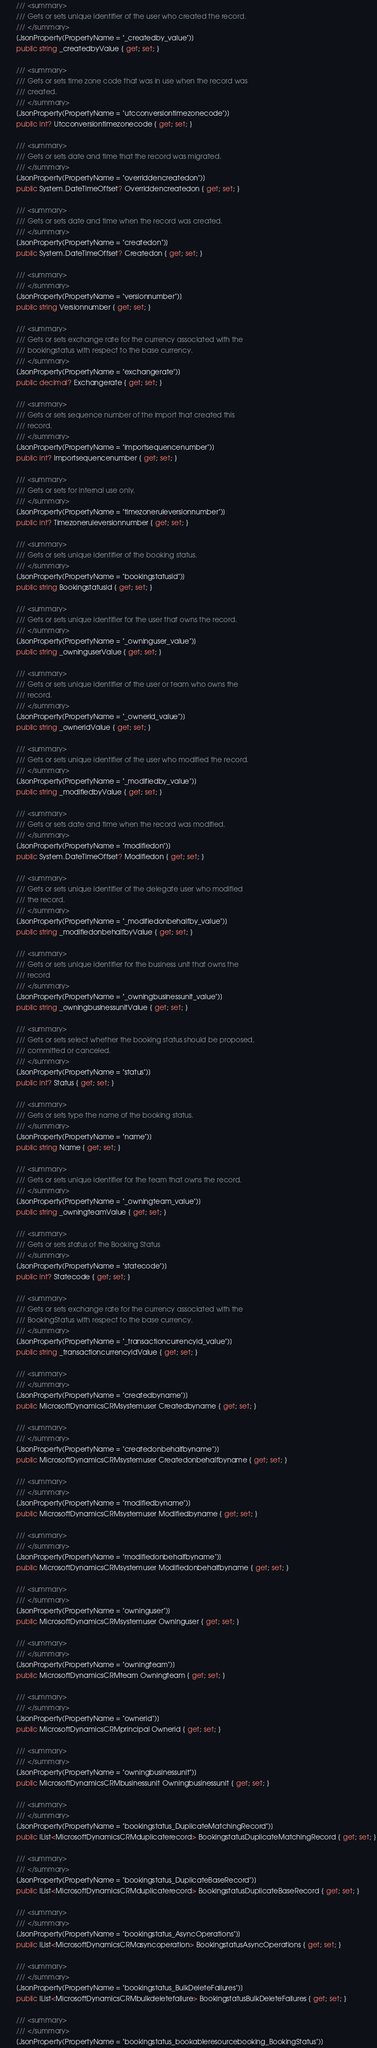Convert code to text. <code><loc_0><loc_0><loc_500><loc_500><_C#_>        /// <summary>
        /// Gets or sets unique identifier of the user who created the record.
        /// </summary>
        [JsonProperty(PropertyName = "_createdby_value")]
        public string _createdbyValue { get; set; }

        /// <summary>
        /// Gets or sets time zone code that was in use when the record was
        /// created.
        /// </summary>
        [JsonProperty(PropertyName = "utcconversiontimezonecode")]
        public int? Utcconversiontimezonecode { get; set; }

        /// <summary>
        /// Gets or sets date and time that the record was migrated.
        /// </summary>
        [JsonProperty(PropertyName = "overriddencreatedon")]
        public System.DateTimeOffset? Overriddencreatedon { get; set; }

        /// <summary>
        /// Gets or sets date and time when the record was created.
        /// </summary>
        [JsonProperty(PropertyName = "createdon")]
        public System.DateTimeOffset? Createdon { get; set; }

        /// <summary>
        /// </summary>
        [JsonProperty(PropertyName = "versionnumber")]
        public string Versionnumber { get; set; }

        /// <summary>
        /// Gets or sets exchange rate for the currency associated with the
        /// bookingstatus with respect to the base currency.
        /// </summary>
        [JsonProperty(PropertyName = "exchangerate")]
        public decimal? Exchangerate { get; set; }

        /// <summary>
        /// Gets or sets sequence number of the import that created this
        /// record.
        /// </summary>
        [JsonProperty(PropertyName = "importsequencenumber")]
        public int? Importsequencenumber { get; set; }

        /// <summary>
        /// Gets or sets for internal use only.
        /// </summary>
        [JsonProperty(PropertyName = "timezoneruleversionnumber")]
        public int? Timezoneruleversionnumber { get; set; }

        /// <summary>
        /// Gets or sets unique identifier of the booking status.
        /// </summary>
        [JsonProperty(PropertyName = "bookingstatusid")]
        public string Bookingstatusid { get; set; }

        /// <summary>
        /// Gets or sets unique identifier for the user that owns the record.
        /// </summary>
        [JsonProperty(PropertyName = "_owninguser_value")]
        public string _owninguserValue { get; set; }

        /// <summary>
        /// Gets or sets unique identifier of the user or team who owns the
        /// record.
        /// </summary>
        [JsonProperty(PropertyName = "_ownerid_value")]
        public string _owneridValue { get; set; }

        /// <summary>
        /// Gets or sets unique identifier of the user who modified the record.
        /// </summary>
        [JsonProperty(PropertyName = "_modifiedby_value")]
        public string _modifiedbyValue { get; set; }

        /// <summary>
        /// Gets or sets date and time when the record was modified.
        /// </summary>
        [JsonProperty(PropertyName = "modifiedon")]
        public System.DateTimeOffset? Modifiedon { get; set; }

        /// <summary>
        /// Gets or sets unique identifier of the delegate user who modified
        /// the record.
        /// </summary>
        [JsonProperty(PropertyName = "_modifiedonbehalfby_value")]
        public string _modifiedonbehalfbyValue { get; set; }

        /// <summary>
        /// Gets or sets unique identifier for the business unit that owns the
        /// record
        /// </summary>
        [JsonProperty(PropertyName = "_owningbusinessunit_value")]
        public string _owningbusinessunitValue { get; set; }

        /// <summary>
        /// Gets or sets select whether the booking status should be proposed,
        /// committed or canceled.
        /// </summary>
        [JsonProperty(PropertyName = "status")]
        public int? Status { get; set; }

        /// <summary>
        /// Gets or sets type the name of the booking status.
        /// </summary>
        [JsonProperty(PropertyName = "name")]
        public string Name { get; set; }

        /// <summary>
        /// Gets or sets unique identifier for the team that owns the record.
        /// </summary>
        [JsonProperty(PropertyName = "_owningteam_value")]
        public string _owningteamValue { get; set; }

        /// <summary>
        /// Gets or sets status of the Booking Status
        /// </summary>
        [JsonProperty(PropertyName = "statecode")]
        public int? Statecode { get; set; }

        /// <summary>
        /// Gets or sets exchange rate for the currency associated with the
        /// BookingStatus with respect to the base currency.
        /// </summary>
        [JsonProperty(PropertyName = "_transactioncurrencyid_value")]
        public string _transactioncurrencyidValue { get; set; }

        /// <summary>
        /// </summary>
        [JsonProperty(PropertyName = "createdbyname")]
        public MicrosoftDynamicsCRMsystemuser Createdbyname { get; set; }

        /// <summary>
        /// </summary>
        [JsonProperty(PropertyName = "createdonbehalfbyname")]
        public MicrosoftDynamicsCRMsystemuser Createdonbehalfbyname { get; set; }

        /// <summary>
        /// </summary>
        [JsonProperty(PropertyName = "modifiedbyname")]
        public MicrosoftDynamicsCRMsystemuser Modifiedbyname { get; set; }

        /// <summary>
        /// </summary>
        [JsonProperty(PropertyName = "modifiedonbehalfbyname")]
        public MicrosoftDynamicsCRMsystemuser Modifiedonbehalfbyname { get; set; }

        /// <summary>
        /// </summary>
        [JsonProperty(PropertyName = "owninguser")]
        public MicrosoftDynamicsCRMsystemuser Owninguser { get; set; }

        /// <summary>
        /// </summary>
        [JsonProperty(PropertyName = "owningteam")]
        public MicrosoftDynamicsCRMteam Owningteam { get; set; }

        /// <summary>
        /// </summary>
        [JsonProperty(PropertyName = "ownerid")]
        public MicrosoftDynamicsCRMprincipal Ownerid { get; set; }

        /// <summary>
        /// </summary>
        [JsonProperty(PropertyName = "owningbusinessunit")]
        public MicrosoftDynamicsCRMbusinessunit Owningbusinessunit { get; set; }

        /// <summary>
        /// </summary>
        [JsonProperty(PropertyName = "bookingstatus_DuplicateMatchingRecord")]
        public IList<MicrosoftDynamicsCRMduplicaterecord> BookingstatusDuplicateMatchingRecord { get; set; }

        /// <summary>
        /// </summary>
        [JsonProperty(PropertyName = "bookingstatus_DuplicateBaseRecord")]
        public IList<MicrosoftDynamicsCRMduplicaterecord> BookingstatusDuplicateBaseRecord { get; set; }

        /// <summary>
        /// </summary>
        [JsonProperty(PropertyName = "bookingstatus_AsyncOperations")]
        public IList<MicrosoftDynamicsCRMasyncoperation> BookingstatusAsyncOperations { get; set; }

        /// <summary>
        /// </summary>
        [JsonProperty(PropertyName = "bookingstatus_BulkDeleteFailures")]
        public IList<MicrosoftDynamicsCRMbulkdeletefailure> BookingstatusBulkDeleteFailures { get; set; }

        /// <summary>
        /// </summary>
        [JsonProperty(PropertyName = "bookingstatus_bookableresourcebooking_BookingStatus")]</code> 